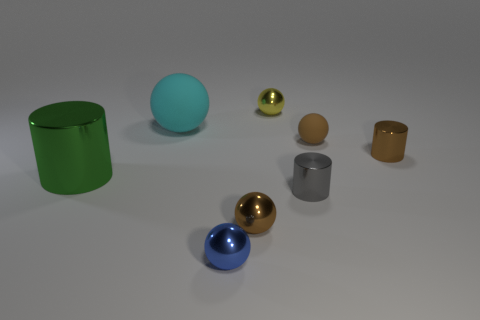There is a matte ball left of the gray shiny cylinder; is it the same size as the object to the left of the big cyan rubber object?
Provide a short and direct response. Yes. How many small things are either yellow objects or rubber spheres?
Offer a very short reply. 2. The small brown sphere to the right of the tiny metal sphere that is behind the big green metal cylinder is made of what material?
Provide a succinct answer. Rubber. Is there a small brown object made of the same material as the big ball?
Provide a succinct answer. Yes. Does the big ball have the same material as the brown sphere behind the gray cylinder?
Provide a short and direct response. Yes. What color is the other shiny thing that is the same size as the cyan thing?
Your response must be concise. Green. There is a rubber ball that is to the left of the small object that is behind the large rubber sphere; what is its size?
Provide a succinct answer. Large. There is a tiny rubber thing; is it the same color as the tiny shiny cylinder that is behind the large shiny object?
Provide a short and direct response. Yes. Is the number of yellow spheres to the right of the yellow object less than the number of spheres?
Your answer should be very brief. Yes. How many other objects are the same size as the blue metallic thing?
Keep it short and to the point. 5. 